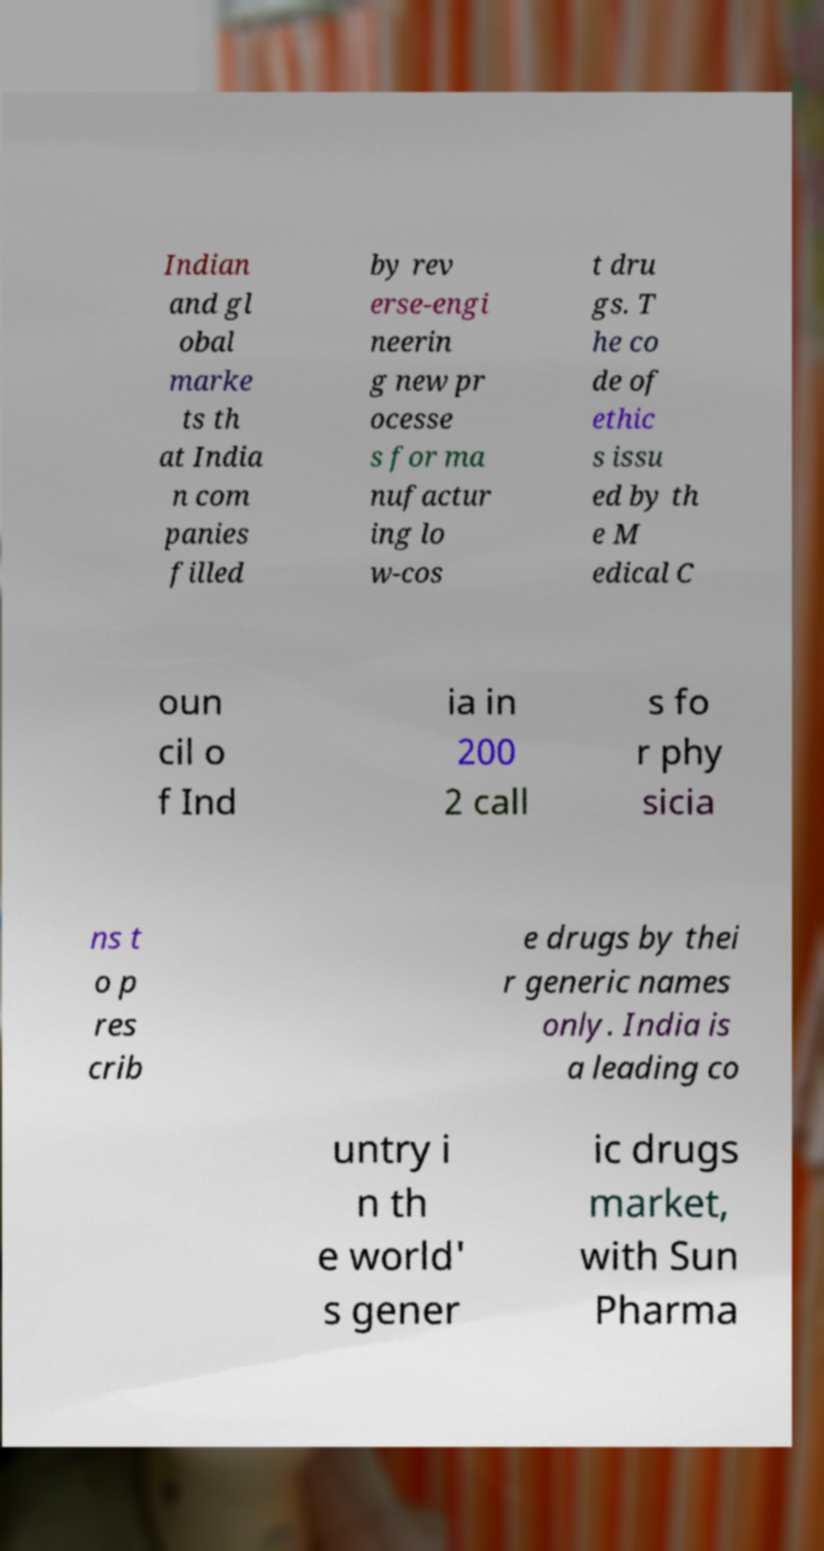What messages or text are displayed in this image? I need them in a readable, typed format. Indian and gl obal marke ts th at India n com panies filled by rev erse-engi neerin g new pr ocesse s for ma nufactur ing lo w-cos t dru gs. T he co de of ethic s issu ed by th e M edical C oun cil o f Ind ia in 200 2 call s fo r phy sicia ns t o p res crib e drugs by thei r generic names only. India is a leading co untry i n th e world' s gener ic drugs market, with Sun Pharma 